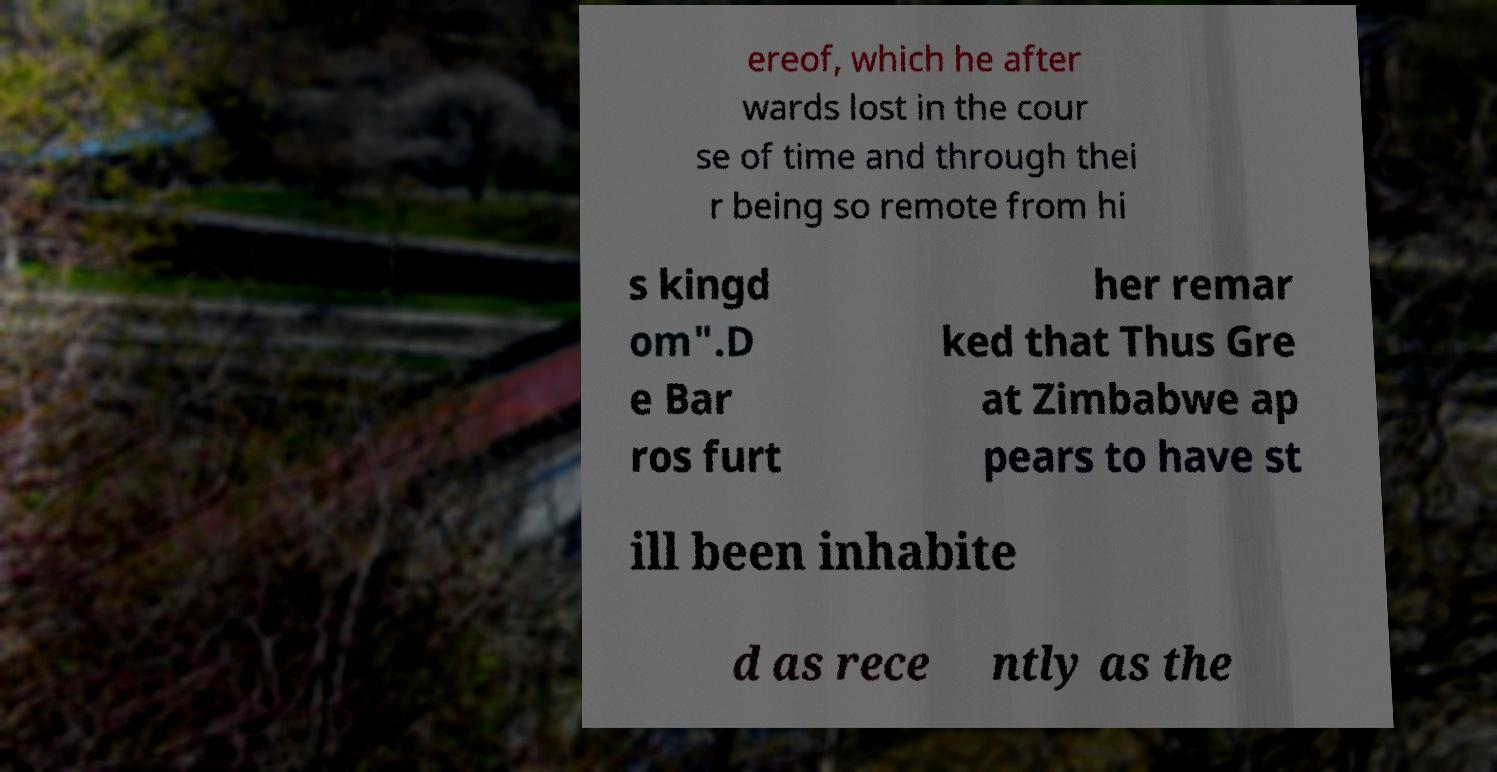Can you read and provide the text displayed in the image?This photo seems to have some interesting text. Can you extract and type it out for me? ereof, which he after wards lost in the cour se of time and through thei r being so remote from hi s kingd om".D e Bar ros furt her remar ked that Thus Gre at Zimbabwe ap pears to have st ill been inhabite d as rece ntly as the 